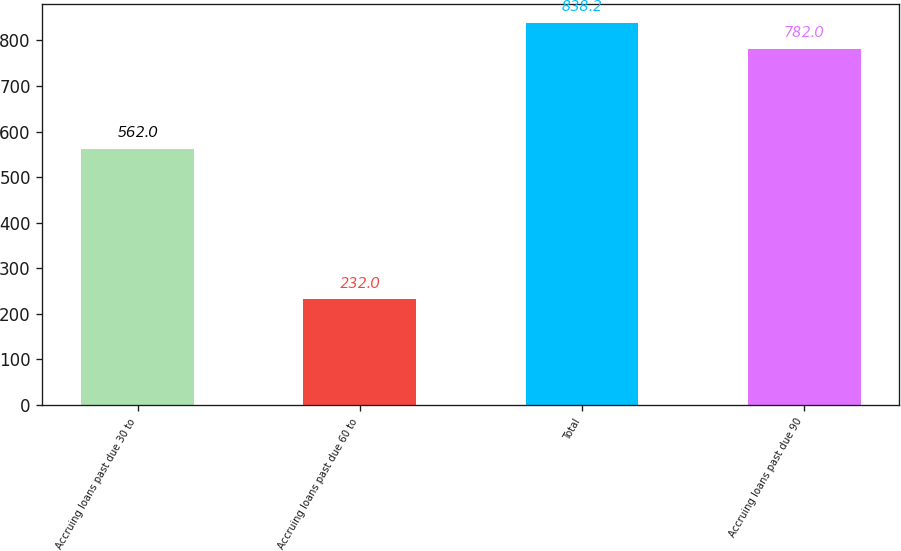<chart> <loc_0><loc_0><loc_500><loc_500><bar_chart><fcel>Accruing loans past due 30 to<fcel>Accruing loans past due 60 to<fcel>Total<fcel>Accruing loans past due 90<nl><fcel>562<fcel>232<fcel>838.2<fcel>782<nl></chart> 